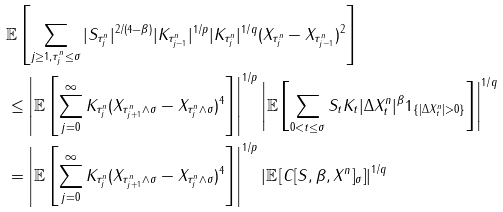Convert formula to latex. <formula><loc_0><loc_0><loc_500><loc_500>& \mathbb { E } \left [ \sum _ { j \geq 1 , \tau ^ { n } _ { j } \leq \sigma } | S _ { \tau ^ { n } _ { j } } | ^ { 2 / ( 4 - \beta ) } | K _ { \tau ^ { n } _ { j - 1 } } | ^ { 1 / p } | K _ { \tau ^ { n } _ { j } } | ^ { 1 / q } ( X _ { \tau ^ { n } _ { j } } - X _ { \tau ^ { n } _ { j - 1 } } ) ^ { 2 } \right ] \\ & \leq \left | \mathbb { E } \left [ \sum _ { j = 0 } ^ { \infty } K _ { \tau ^ { n } _ { j } } ( X _ { \tau ^ { n } _ { j + 1 } \wedge \sigma } - X _ { \tau ^ { n } _ { j } \wedge \sigma } ) ^ { 4 } \right ] \right | ^ { 1 / p } \left | \mathbb { E } \left [ \sum _ { 0 < t \leq \sigma } S _ { t } K _ { t } | \Delta X ^ { n } _ { t } | ^ { \beta } 1 _ { \{ | \Delta X ^ { n } _ { t } | > 0 \} } \right ] \right | ^ { 1 / q } \\ & = \left | \mathbb { E } \left [ \sum _ { j = 0 } ^ { \infty } K _ { \tau ^ { n } _ { j } } ( X _ { \tau ^ { n } _ { j + 1 } \wedge \sigma } - X _ { \tau ^ { n } _ { j } \wedge \sigma } ) ^ { 4 } \right ] \right | ^ { 1 / p } \left | \mathbb { E } \left [ C [ S , \beta , X ^ { n } ] _ { \sigma } \right ] \right | ^ { 1 / q }</formula> 